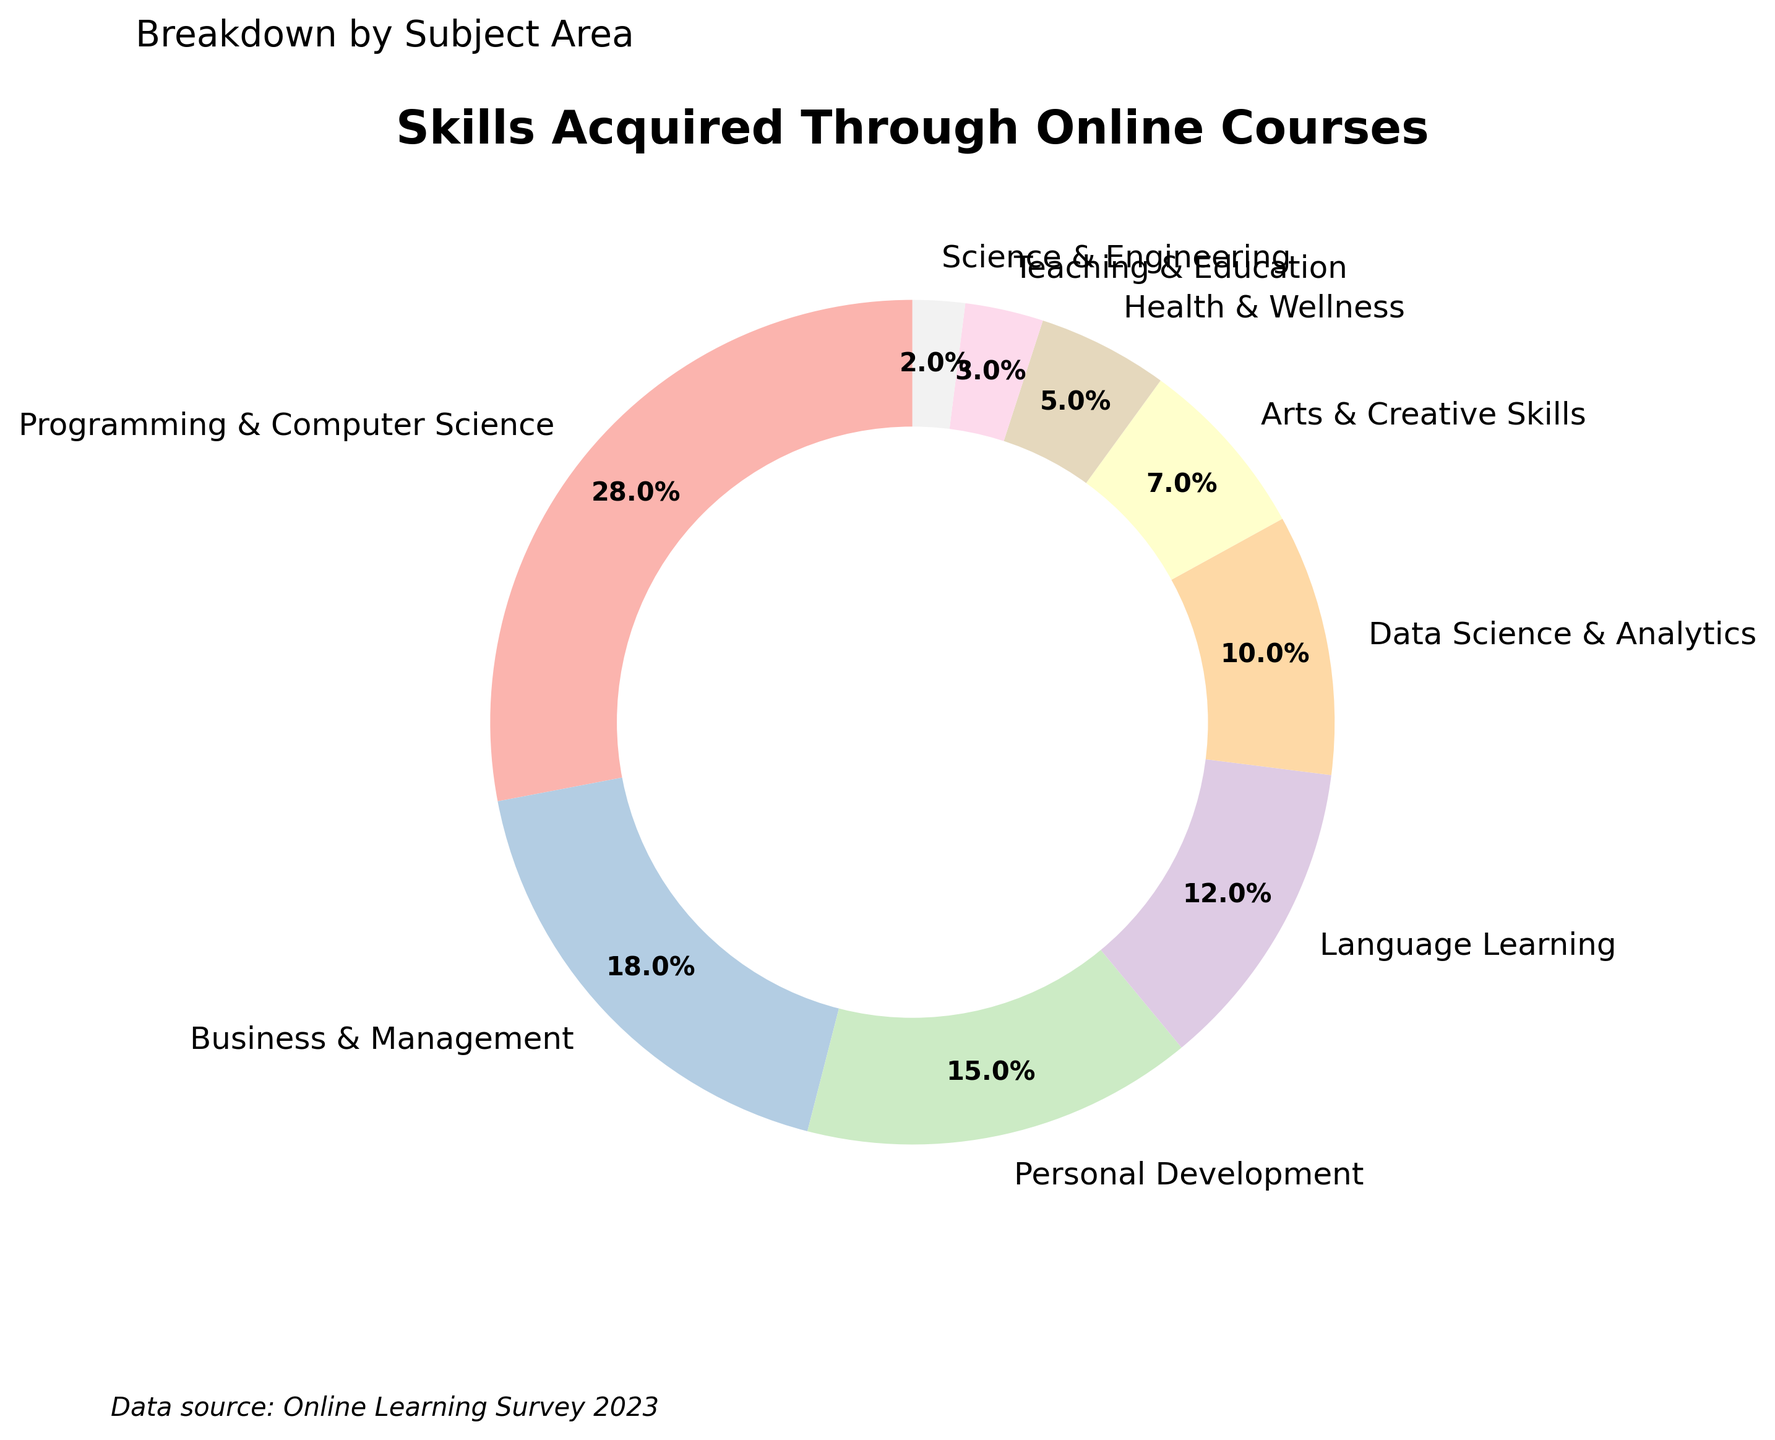What subject area has the highest percentage of skills acquired? Look at the pie chart and identify the segment with the largest percentage label. The "Programming & Computer Science" segment has the highest percentage, 28%.
Answer: Programming & Computer Science Which two subject areas combined make up the largest portion of the chart? Add the percentages of "Programming & Computer Science" (28%) and "Business & Management" (18%). Their sum is 28% + 18% = 46%, the largest combined portion.
Answer: Programming & Computer Science and Business & Management How much more popular is "Business & Management" compared to "Health & Wellness"? Subtract the percentage of "Health & Wellness" (5%) from "Business & Management" (18%). 18% - 5% = 13%.
Answer: 13% What is the combined percentage of the bottom three subject areas? Add the percentages of "Science & Engineering" (2%), "Teaching & Education" (3%), and "Health & Wellness" (5%). Their combined percentage is 2% + 3% + 5% = 10%.
Answer: 10% Which subject area is represented by the lightest colored segment in the pie chart? Look for the segment with the lightest color in the color scheme used. In this case, "Science & Engineering," which has the smallest percentage (2%), is often represented with a lighter color.
Answer: Science & Engineering How does the percentage of "Data Science & Analytics" compare to "Arts & Creative Skills"? Look at the percentages for "Data Science & Analytics" (10%) and "Arts & Creative Skills" (7%). "Data Science & Analytics" has a higher percentage.
Answer: Data Science & Analytics is 3% higher than Arts & Creative Skills What is the average percentage of all subject areas shown in the chart? Add all the percentages and then divide by the number of subject areas. (28 + 18 + 15 + 12 + 10 + 7 + 5 + 3 + 2) / 9 ≈ 11.22%.
Answer: 11.22% By how much does the percentage of "Language Learning" exceed "Personal Development"? Subtract the percentage of "Personal Development" (15%) from "Language Learning" (12%). However, 15% - 12% results in -3%, indicating "Language Learning" does not exceed "Personal Development". It's 3% less.
Answer: -3% 